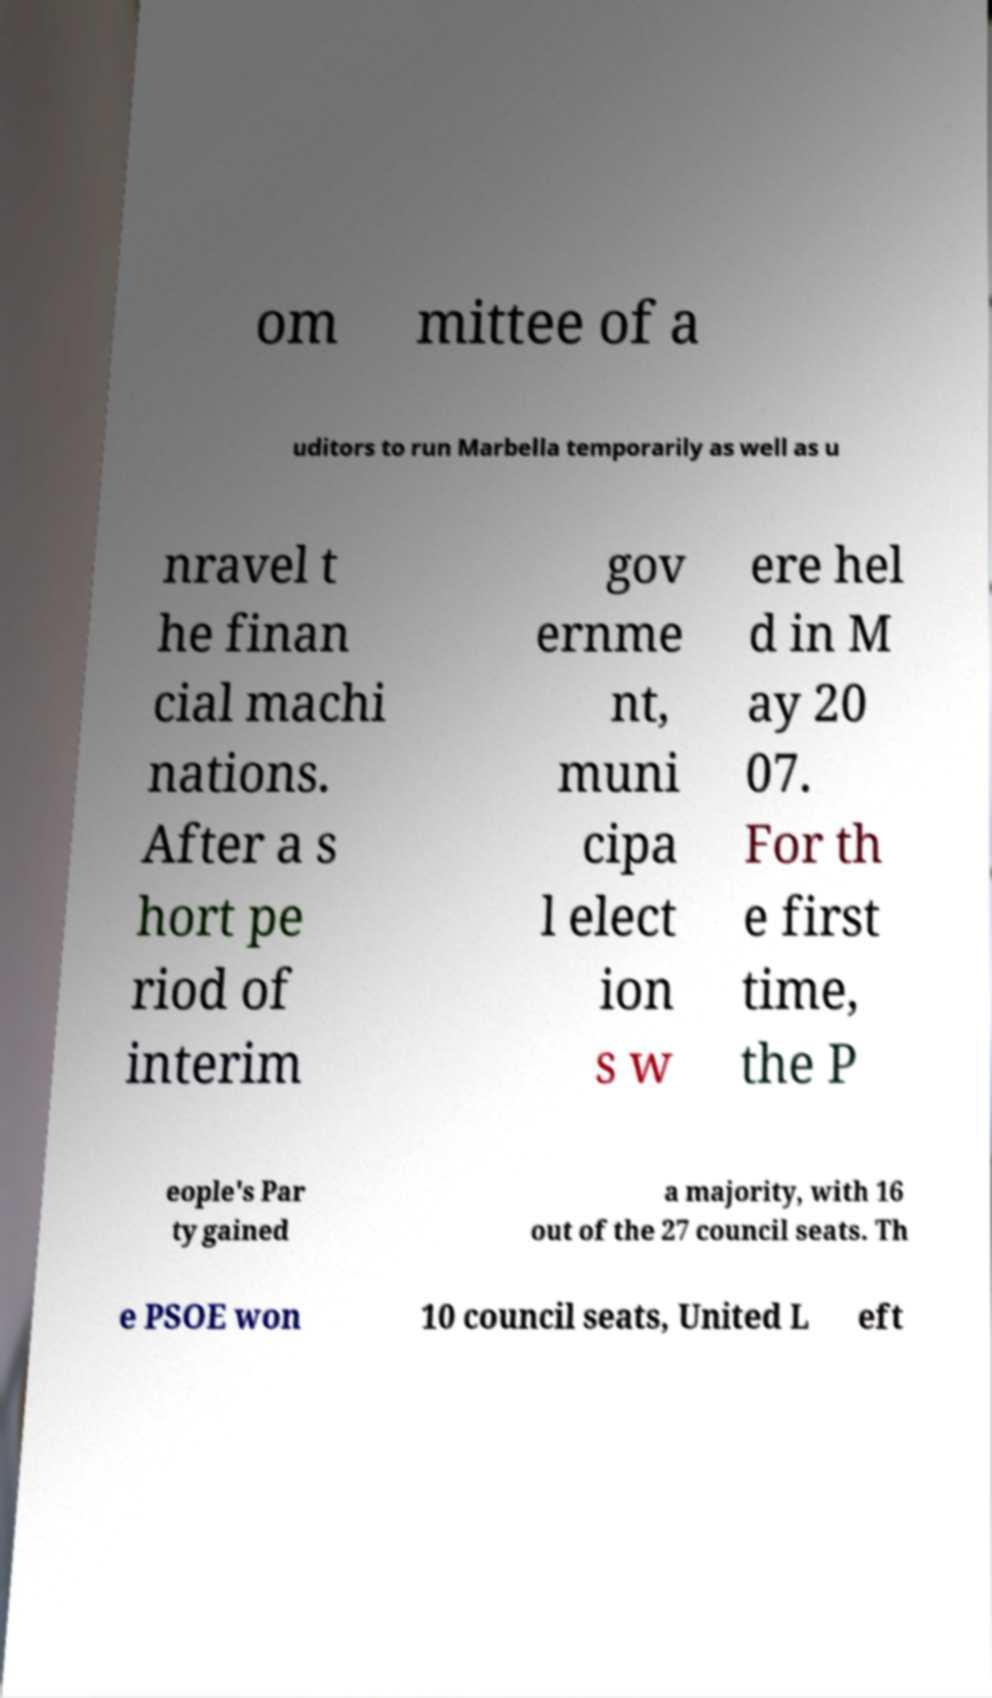There's text embedded in this image that I need extracted. Can you transcribe it verbatim? om mittee of a uditors to run Marbella temporarily as well as u nravel t he finan cial machi nations. After a s hort pe riod of interim gov ernme nt, muni cipa l elect ion s w ere hel d in M ay 20 07. For th e first time, the P eople's Par ty gained a majority, with 16 out of the 27 council seats. Th e PSOE won 10 council seats, United L eft 